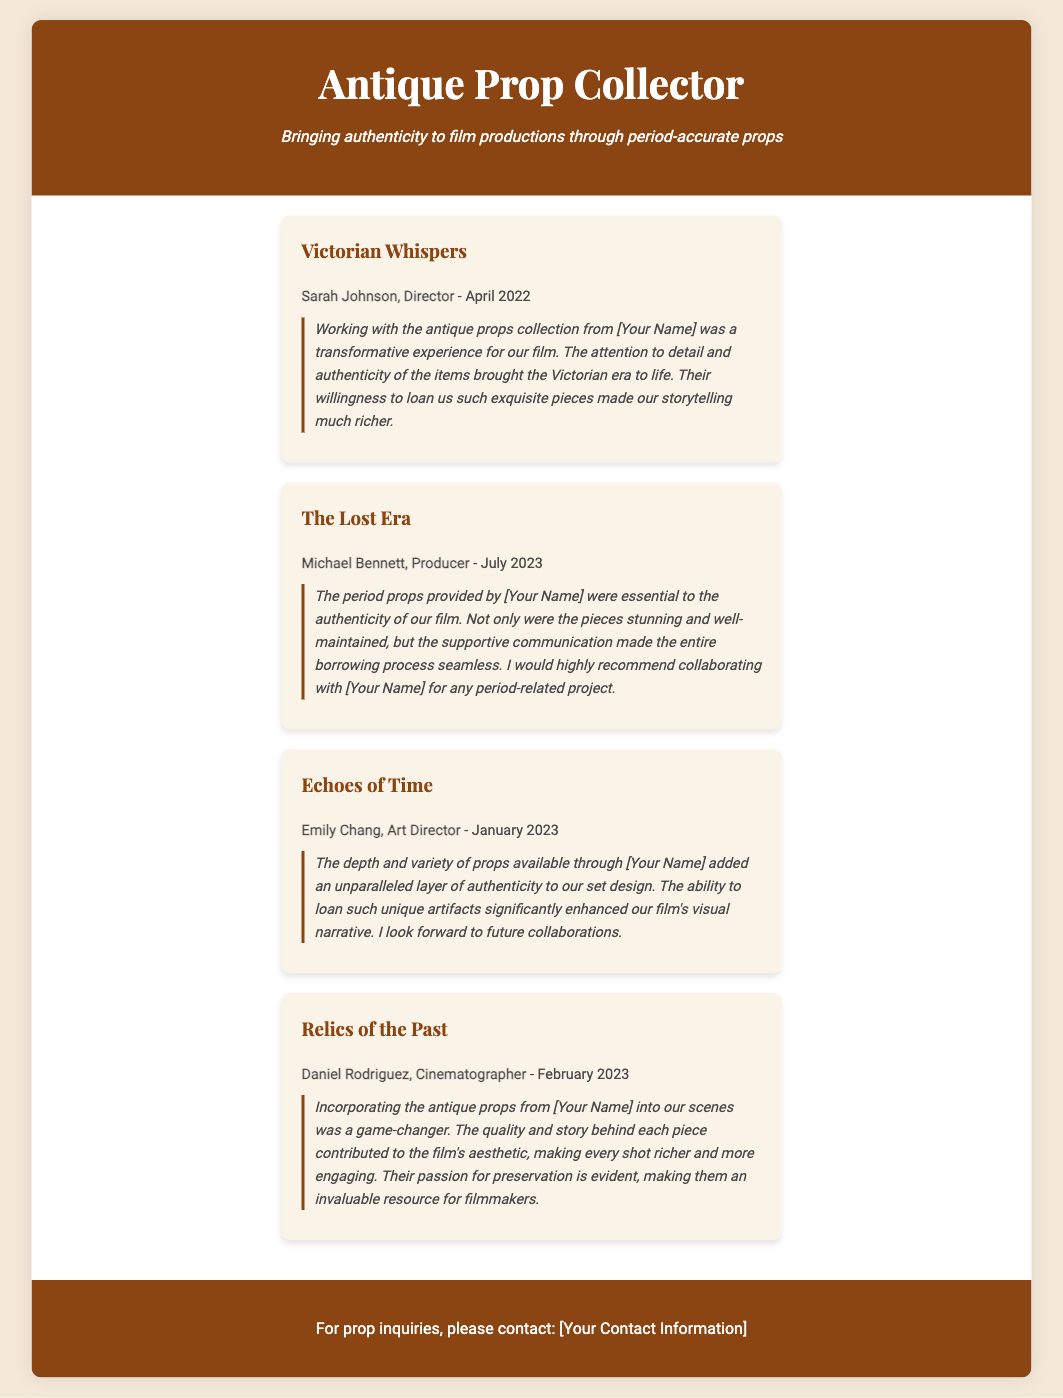What is the name of the director who provided a testimonial? The document lists Sarah Johnson as a director who provided a testimonial for "Victorian Whispers".
Answer: Sarah Johnson In which month and year did Michael Bennett, the producer, provide his testimonial? Michael Bennett provided his testimonial in July 2023.
Answer: July 2023 How does Emily Chang describe the props available through [Your Name]? Emily Chang describes the props as adding an unparalleled layer of authenticity to the set design.
Answer: Unparalleled layer of authenticity Which project did Daniel Rodriguez work on when using the antique props? Daniel Rodriguez worked on "Relics of the Past" when incorporating the antique props.
Answer: Relics of the Past What common theme is highlighted in all the testimonials? The common theme is the authenticity and quality of the antique props provided for film productions.
Answer: Authenticity and quality of props How many testimonials are provided in the document? There are four testimonials mentioned in the document.
Answer: Four testimonials What type of resource does the document indicate [Your Name] represents for filmmakers? The document indicates that [Your Name] is an invaluable resource for filmmakers regarding period props.
Answer: Invaluable resource What contact information detail is mentioned in the footer? The footer states that contact information will be provided for prop inquiries.
Answer: Prop inquiries contact information 